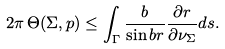Convert formula to latex. <formula><loc_0><loc_0><loc_500><loc_500>2 \pi \, \Theta ( \Sigma , p ) \leq \int _ { \Gamma } \frac { b } { \sin b r } \frac { \partial r } { \partial \nu _ { \Sigma } } d s .</formula> 